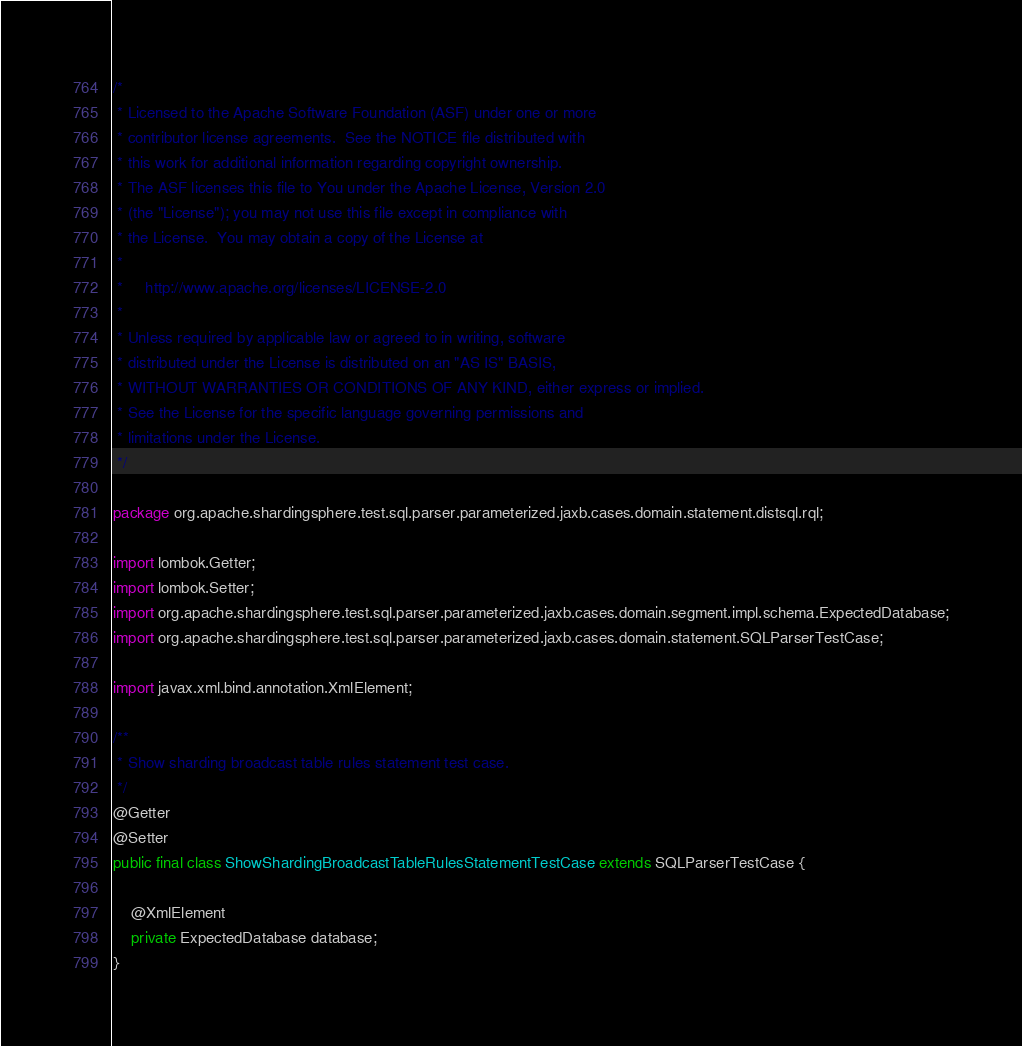Convert code to text. <code><loc_0><loc_0><loc_500><loc_500><_Java_>/*
 * Licensed to the Apache Software Foundation (ASF) under one or more
 * contributor license agreements.  See the NOTICE file distributed with
 * this work for additional information regarding copyright ownership.
 * The ASF licenses this file to You under the Apache License, Version 2.0
 * (the "License"); you may not use this file except in compliance with
 * the License.  You may obtain a copy of the License at
 *
 *     http://www.apache.org/licenses/LICENSE-2.0
 *
 * Unless required by applicable law or agreed to in writing, software
 * distributed under the License is distributed on an "AS IS" BASIS,
 * WITHOUT WARRANTIES OR CONDITIONS OF ANY KIND, either express or implied.
 * See the License for the specific language governing permissions and
 * limitations under the License.
 */

package org.apache.shardingsphere.test.sql.parser.parameterized.jaxb.cases.domain.statement.distsql.rql;

import lombok.Getter;
import lombok.Setter;
import org.apache.shardingsphere.test.sql.parser.parameterized.jaxb.cases.domain.segment.impl.schema.ExpectedDatabase;
import org.apache.shardingsphere.test.sql.parser.parameterized.jaxb.cases.domain.statement.SQLParserTestCase;

import javax.xml.bind.annotation.XmlElement;

/**
 * Show sharding broadcast table rules statement test case.
 */
@Getter
@Setter
public final class ShowShardingBroadcastTableRulesStatementTestCase extends SQLParserTestCase {
    
    @XmlElement
    private ExpectedDatabase database;
}
</code> 